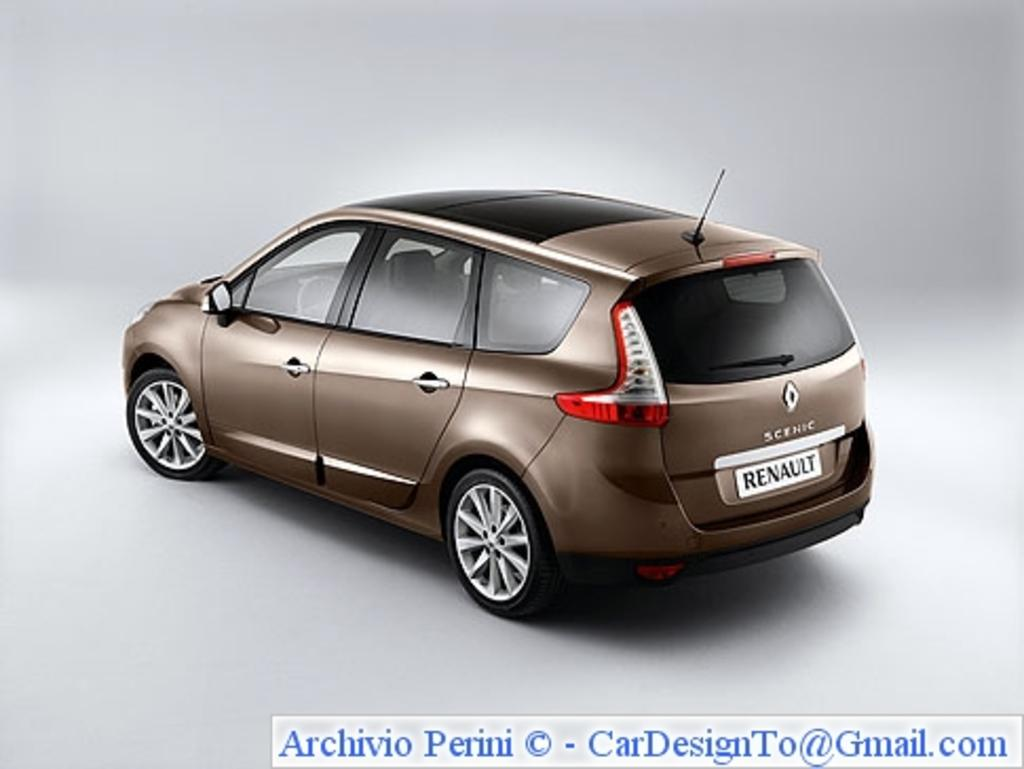What is the main subject of the image? There is a car in the center of the image. What color is the background of the image? The background of the image is white. Is there any text present in the image? Yes, there is text at the bottom of the image. Can you see any cows grazing near the seashore in the image? There are no cows or seashore present in the image; it features a car with a white background and text at the bottom. 